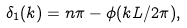Convert formula to latex. <formula><loc_0><loc_0><loc_500><loc_500>\delta _ { 1 } ( k ) = n \pi - \phi ( k L / 2 \pi ) ,</formula> 